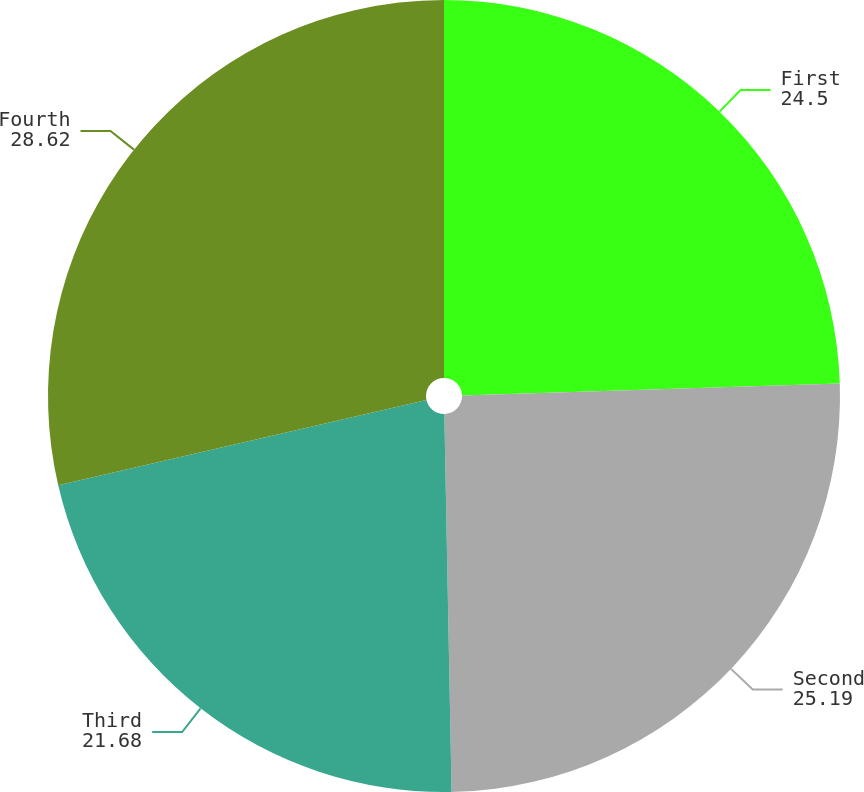Convert chart to OTSL. <chart><loc_0><loc_0><loc_500><loc_500><pie_chart><fcel>First<fcel>Second<fcel>Third<fcel>Fourth<nl><fcel>24.5%<fcel>25.19%<fcel>21.68%<fcel>28.62%<nl></chart> 